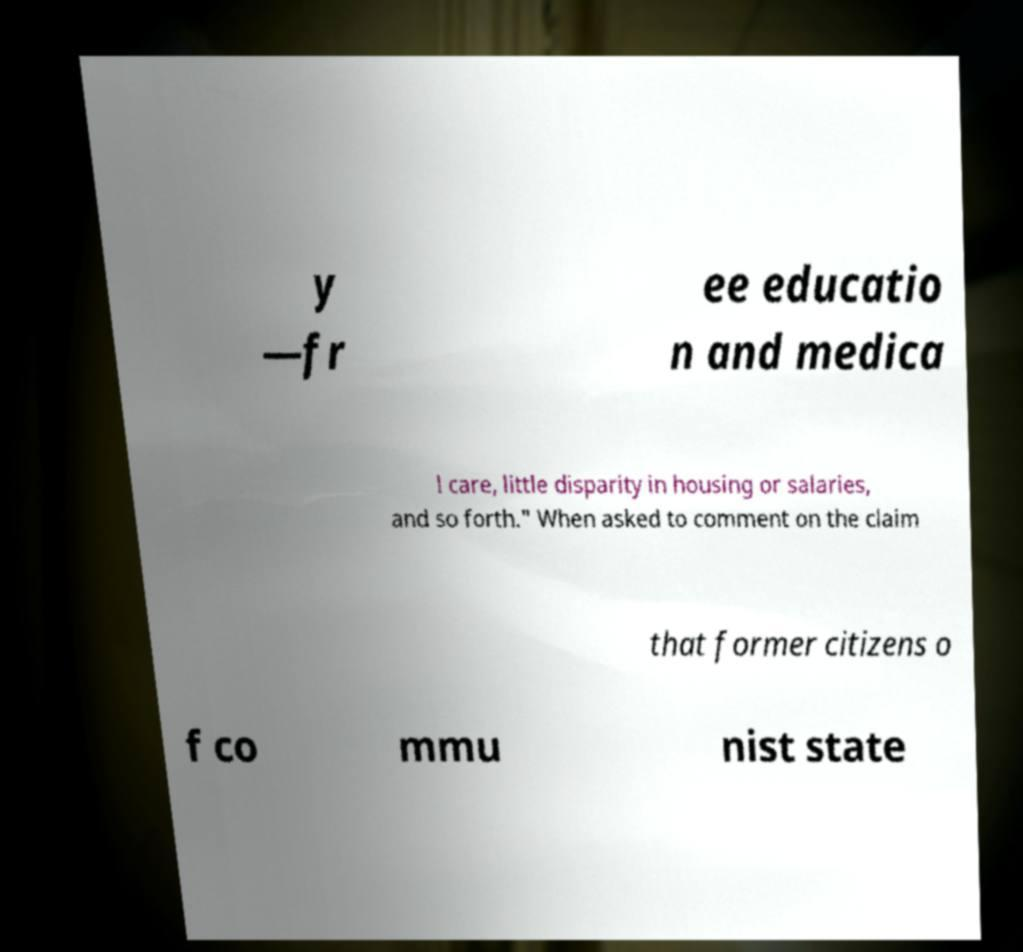I need the written content from this picture converted into text. Can you do that? y —fr ee educatio n and medica l care, little disparity in housing or salaries, and so forth." When asked to comment on the claim that former citizens o f co mmu nist state 